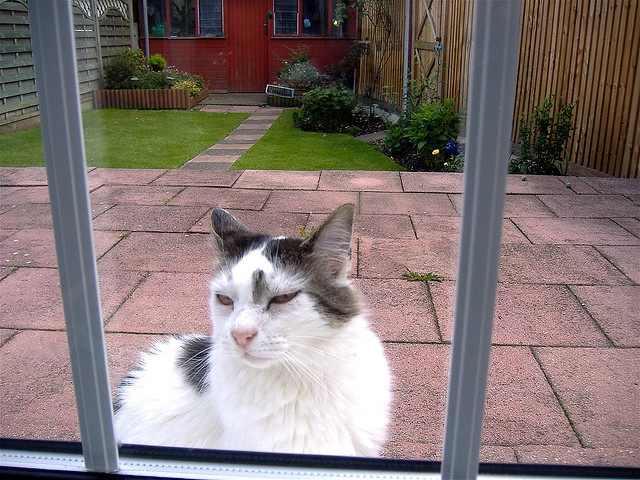Describe the objects in this image and their specific colors. I can see a cat in gray, white, darkgray, and pink tones in this image. 